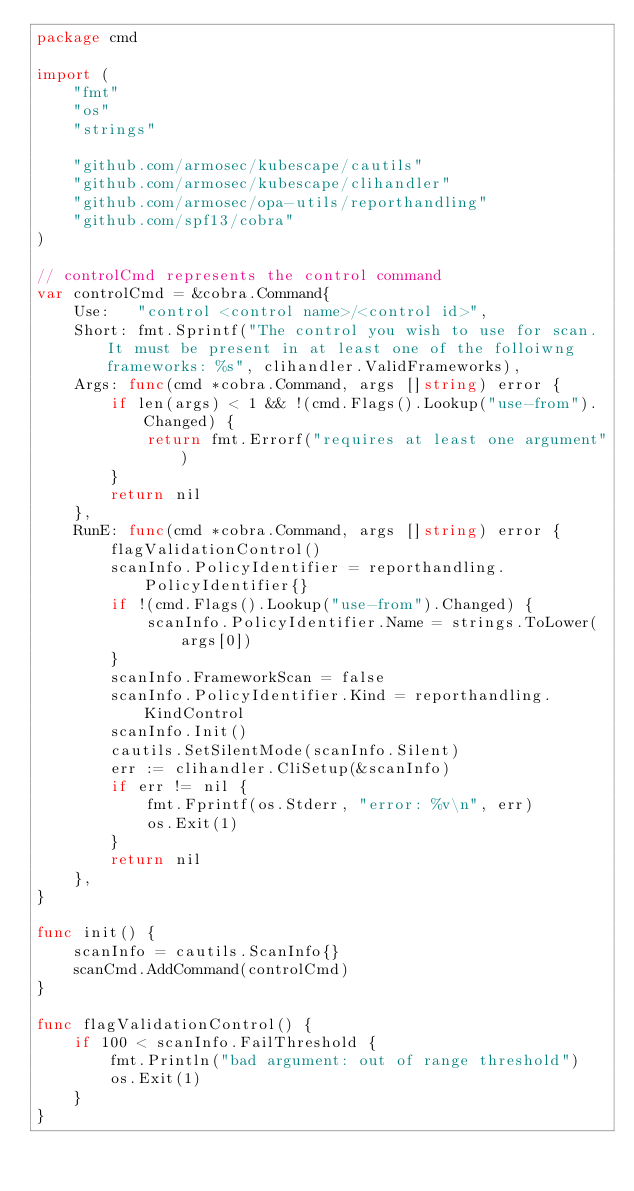<code> <loc_0><loc_0><loc_500><loc_500><_Go_>package cmd

import (
	"fmt"
	"os"
	"strings"

	"github.com/armosec/kubescape/cautils"
	"github.com/armosec/kubescape/clihandler"
	"github.com/armosec/opa-utils/reporthandling"
	"github.com/spf13/cobra"
)

// controlCmd represents the control command
var controlCmd = &cobra.Command{
	Use:   "control <control name>/<control id>",
	Short: fmt.Sprintf("The control you wish to use for scan. It must be present in at least one of the folloiwng frameworks: %s", clihandler.ValidFrameworks),
	Args: func(cmd *cobra.Command, args []string) error {
		if len(args) < 1 && !(cmd.Flags().Lookup("use-from").Changed) {
			return fmt.Errorf("requires at least one argument")
		}
		return nil
	},
	RunE: func(cmd *cobra.Command, args []string) error {
		flagValidationControl()
		scanInfo.PolicyIdentifier = reporthandling.PolicyIdentifier{}
		if !(cmd.Flags().Lookup("use-from").Changed) {
			scanInfo.PolicyIdentifier.Name = strings.ToLower(args[0])
		}
		scanInfo.FrameworkScan = false
		scanInfo.PolicyIdentifier.Kind = reporthandling.KindControl
		scanInfo.Init()
		cautils.SetSilentMode(scanInfo.Silent)
		err := clihandler.CliSetup(&scanInfo)
		if err != nil {
			fmt.Fprintf(os.Stderr, "error: %v\n", err)
			os.Exit(1)
		}
		return nil
	},
}

func init() {
	scanInfo = cautils.ScanInfo{}
	scanCmd.AddCommand(controlCmd)
}

func flagValidationControl() {
	if 100 < scanInfo.FailThreshold {
		fmt.Println("bad argument: out of range threshold")
		os.Exit(1)
	}
}
</code> 